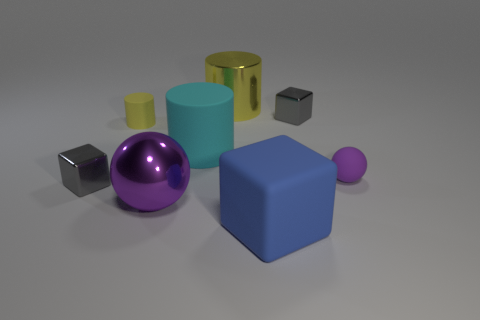Is the shape of the purple thing behind the large purple metallic thing the same as the gray object that is to the right of the large yellow metallic cylinder?
Provide a succinct answer. No. Is the big yellow object made of the same material as the small purple sphere?
Your answer should be very brief. No. There is a yellow object in front of the gray thing that is behind the gray cube in front of the yellow matte cylinder; how big is it?
Your answer should be compact. Small. How many other objects are the same color as the shiny ball?
Your response must be concise. 1. What shape is the blue matte object that is the same size as the cyan rubber cylinder?
Provide a succinct answer. Cube. What number of large things are gray cubes or metallic cylinders?
Your response must be concise. 1. Are there any small yellow cylinders behind the cylinder to the right of the large rubber thing behind the tiny purple ball?
Give a very brief answer. No. Are there any yellow shiny spheres that have the same size as the purple matte object?
Your answer should be compact. No. What is the material of the cyan object that is the same size as the blue matte block?
Your answer should be very brief. Rubber. There is a yellow shiny cylinder; does it have the same size as the ball in front of the tiny purple matte object?
Provide a succinct answer. Yes. 